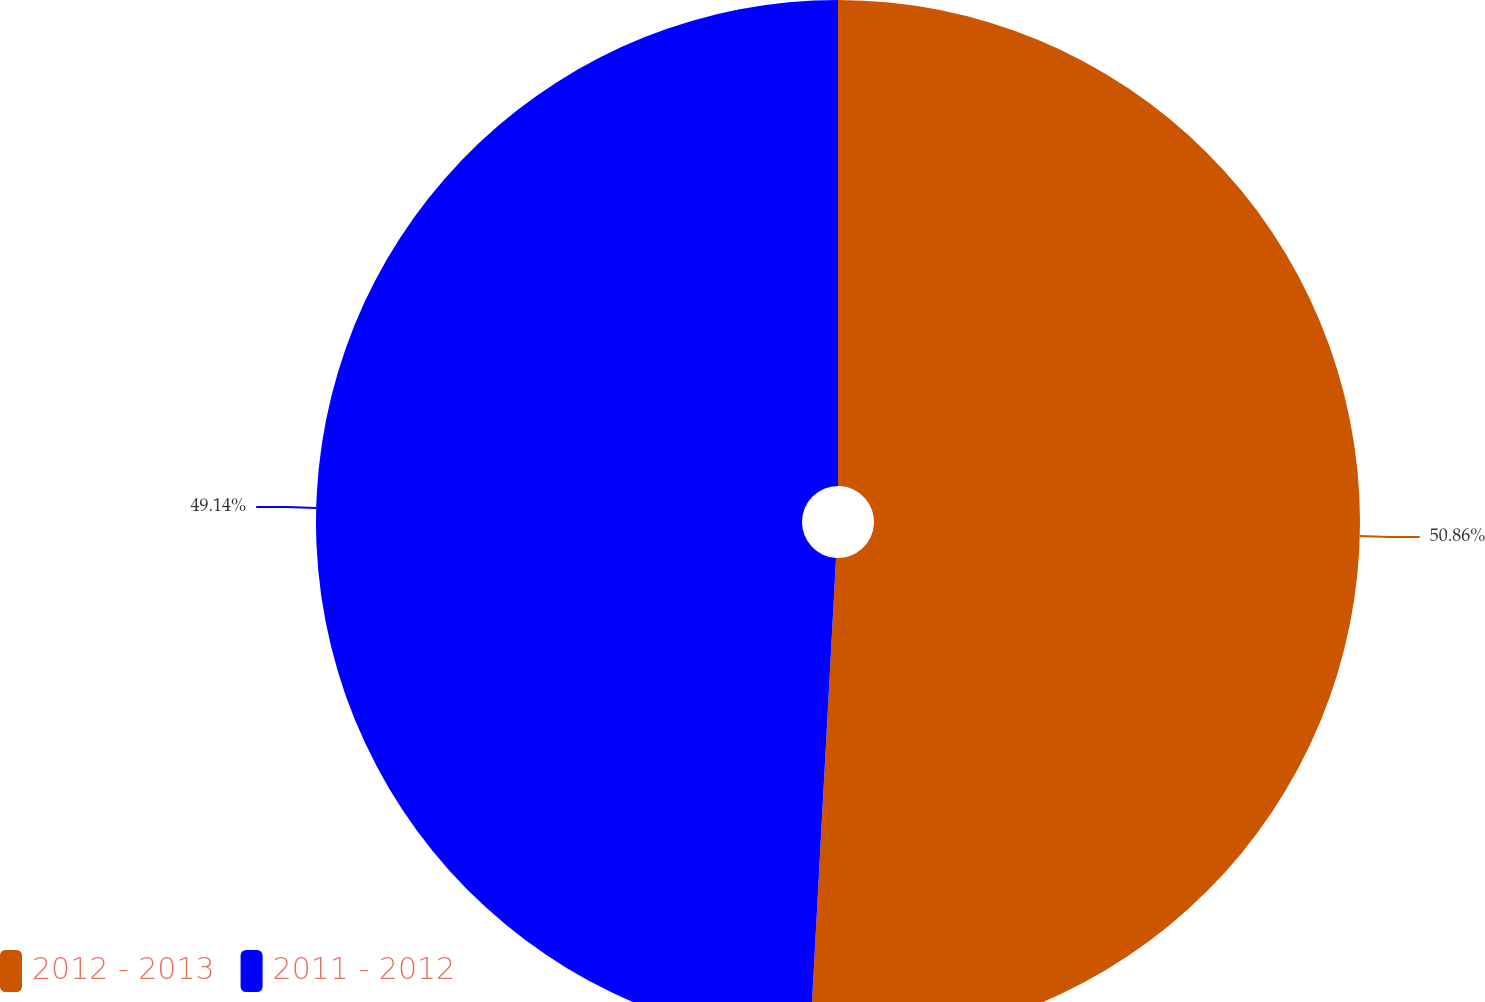Convert chart. <chart><loc_0><loc_0><loc_500><loc_500><pie_chart><fcel>2012 - 2013<fcel>2011 - 2012<nl><fcel>50.86%<fcel>49.14%<nl></chart> 